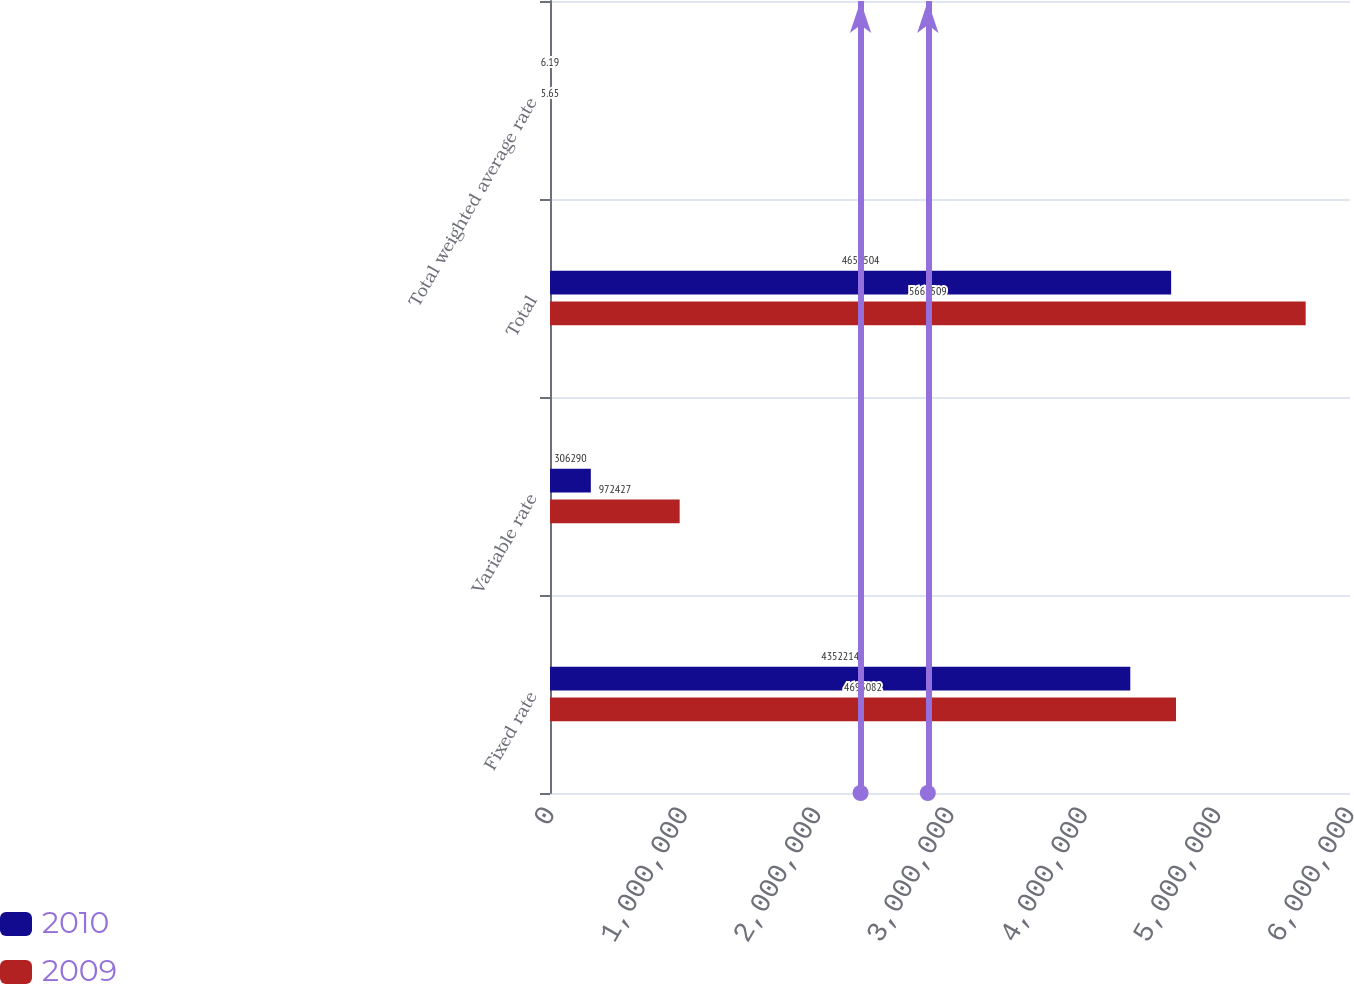Convert chart. <chart><loc_0><loc_0><loc_500><loc_500><stacked_bar_chart><ecel><fcel>Fixed rate<fcel>Variable rate<fcel>Total<fcel>Total weighted average rate<nl><fcel>2010<fcel>4.35221e+06<fcel>306290<fcel>4.6585e+06<fcel>6.19<nl><fcel>2009<fcel>4.69508e+06<fcel>972427<fcel>5.66751e+06<fcel>5.65<nl></chart> 